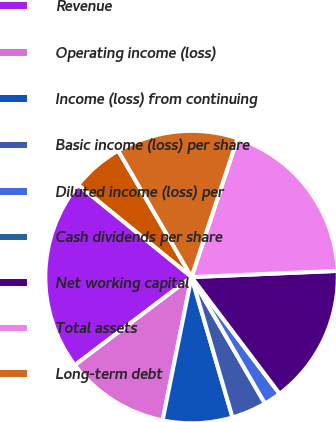Convert chart. <chart><loc_0><loc_0><loc_500><loc_500><pie_chart><fcel>Millions of dollars except per<fcel>Revenue<fcel>Operating income (loss)<fcel>Income (loss) from continuing<fcel>Basic income (loss) per share<fcel>Diluted income (loss) per<fcel>Cash dividends per share<fcel>Net working capital<fcel>Total assets<fcel>Long-term debt<nl><fcel>5.77%<fcel>21.15%<fcel>11.54%<fcel>7.69%<fcel>3.85%<fcel>1.92%<fcel>0.0%<fcel>15.38%<fcel>19.23%<fcel>13.46%<nl></chart> 